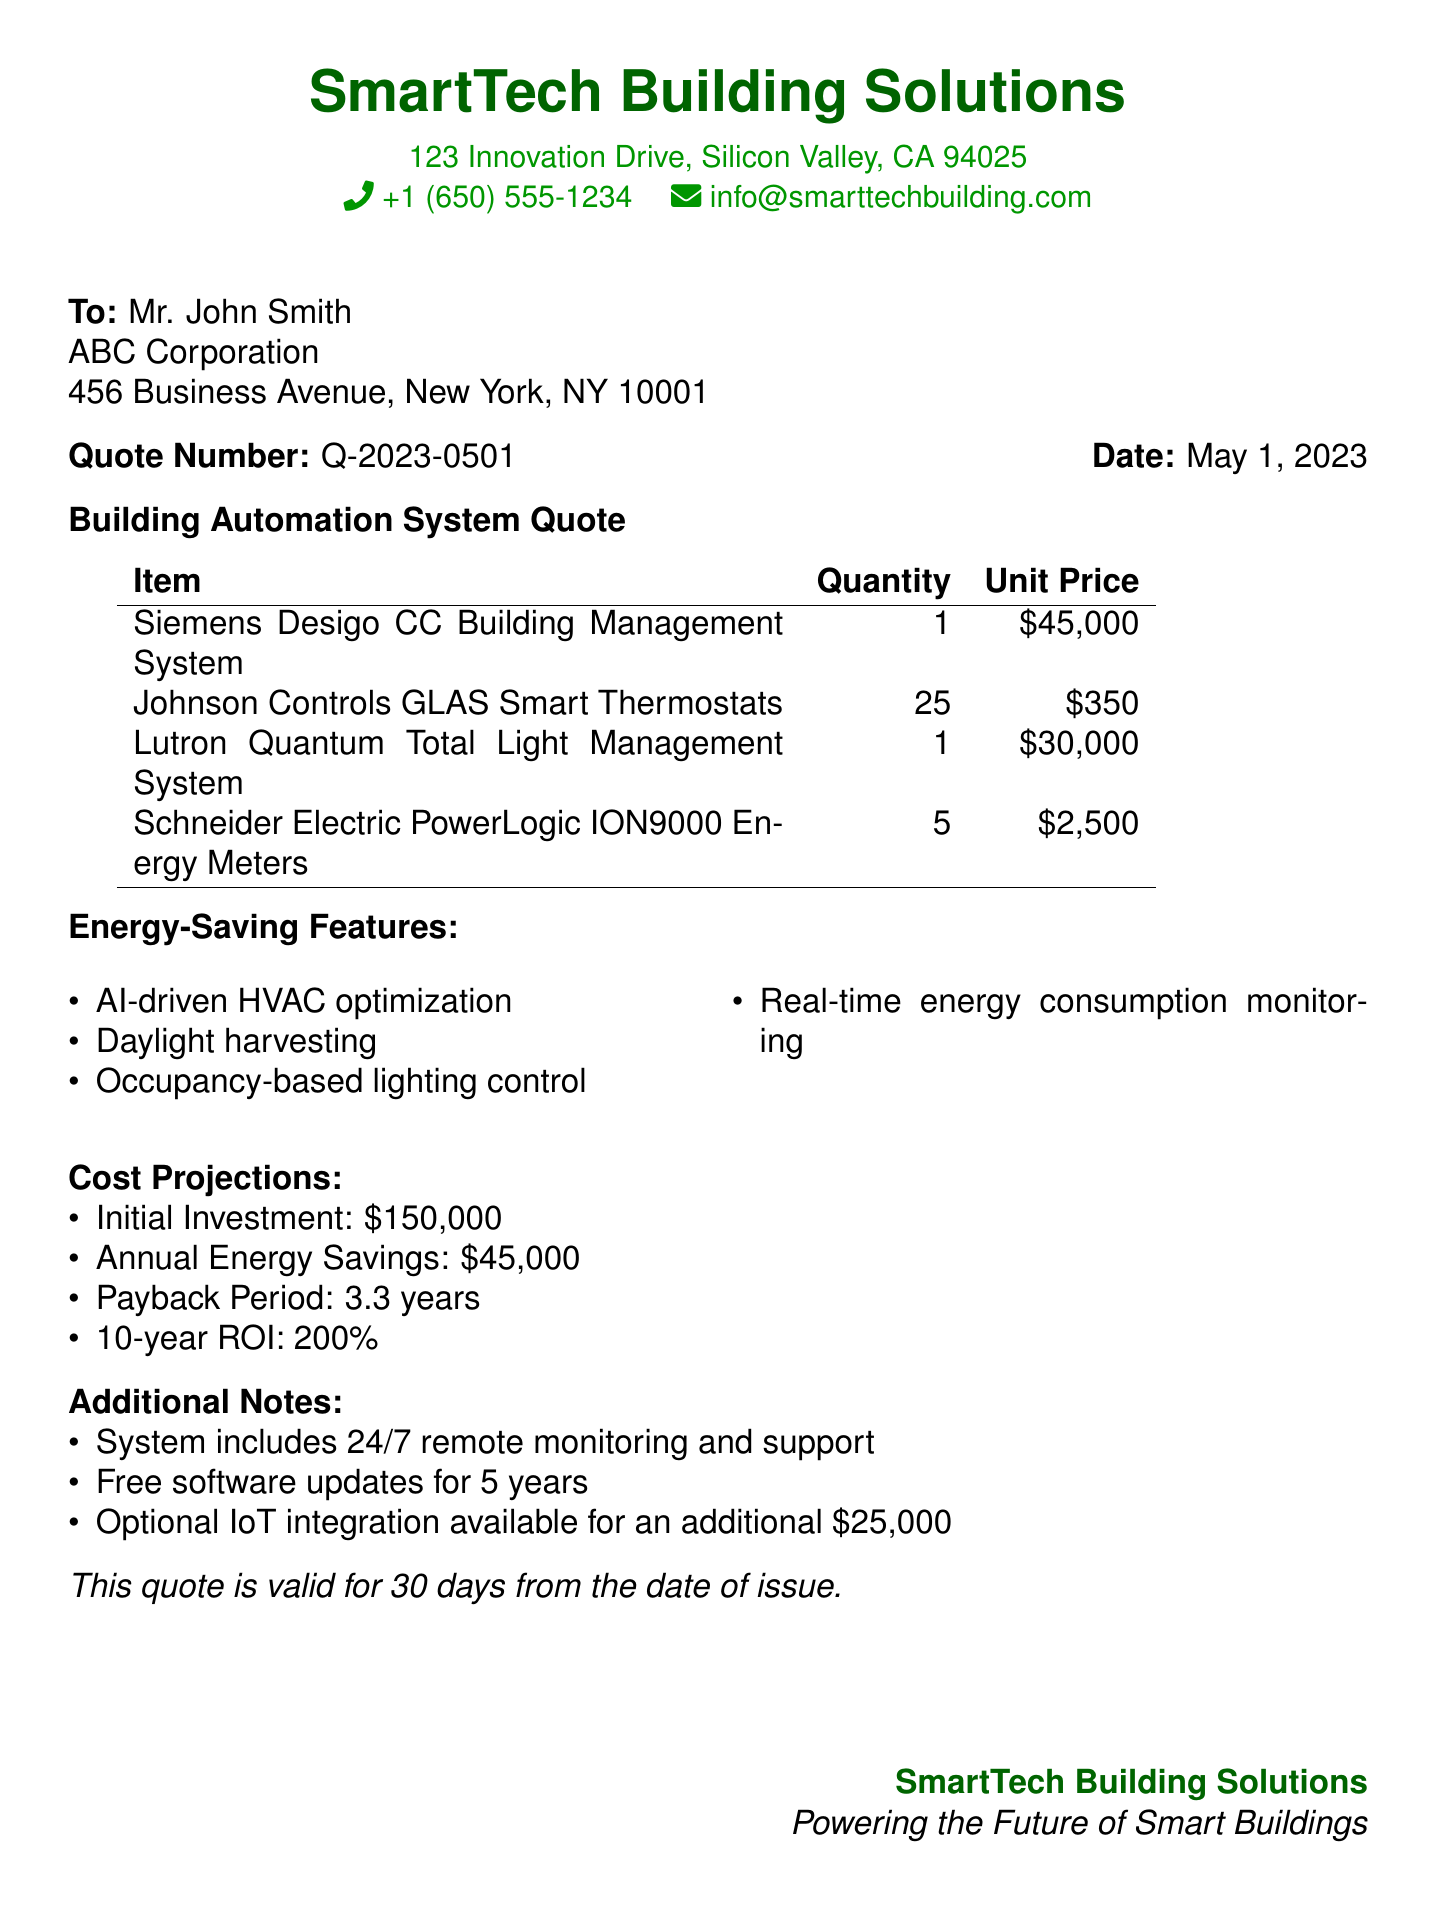What is the quote number? The quote number is specified for identification in the document, which is Q-2023-0501.
Answer: Q-2023-0501 What is the total initial investment? The total initial investment is stated clearly in the cost projections, which is $150,000.
Answer: $150,000 Who is the recipient of the quote? The recipient is mentioned at the start of the document, which is Mr. John Smith.
Answer: Mr. John Smith How many smart thermostats are included in the quote? The quantity of smart thermostats is provided in the items list, which is 25.
Answer: 25 What feature involves optimizing HVAC systems using AI? The energy-saving feature that utilizes AI is named AI-driven HVAC optimization.
Answer: AI-driven HVAC optimization What is the annual energy savings projected? The document specifies the projected annual energy savings, which amounts to $45,000.
Answer: $45,000 What is the payback period for the investment? The payback period is listed in the cost projections as 3.3 years.
Answer: 3.3 years What additional service is included for free for 5 years? The service that includes free updates for 5 years is software updates.
Answer: software updates What is the total price for the Lutron Quantum Total Light Management System? The unit price of the Lutron system is given, and it is $30,000.
Answer: $30,000 